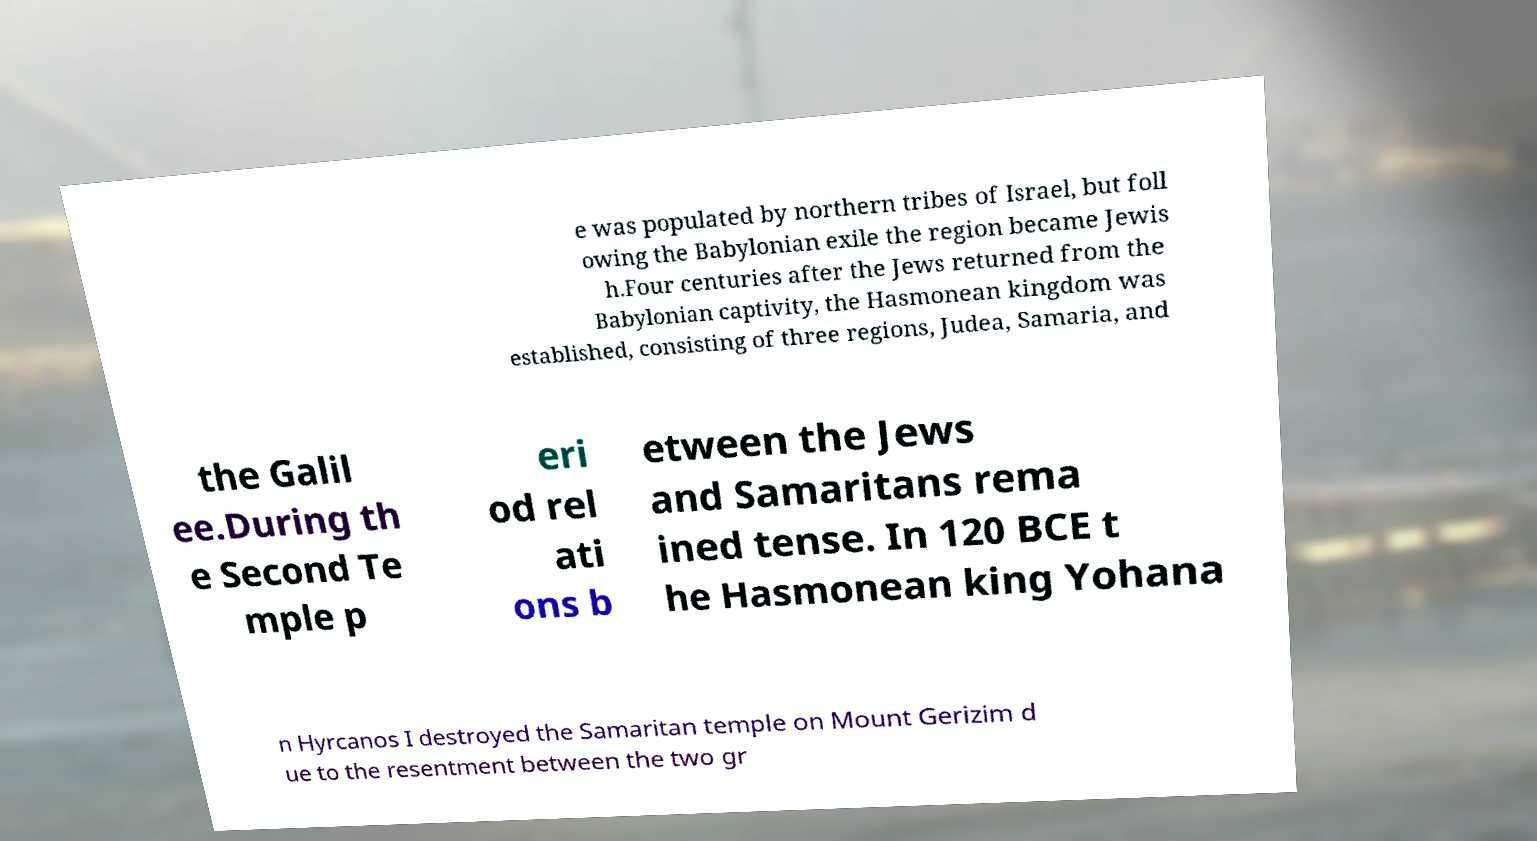What messages or text are displayed in this image? I need them in a readable, typed format. e was populated by northern tribes of Israel, but foll owing the Babylonian exile the region became Jewis h.Four centuries after the Jews returned from the Babylonian captivity, the Hasmonean kingdom was established, consisting of three regions, Judea, Samaria, and the Galil ee.During th e Second Te mple p eri od rel ati ons b etween the Jews and Samaritans rema ined tense. In 120 BCE t he Hasmonean king Yohana n Hyrcanos I destroyed the Samaritan temple on Mount Gerizim d ue to the resentment between the two gr 